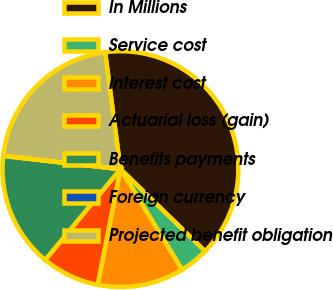<chart> <loc_0><loc_0><loc_500><loc_500><pie_chart><fcel>In Millions<fcel>Service cost<fcel>Interest cost<fcel>Actuarial loss (gain)<fcel>Benefits payments<fcel>Foreign currency<fcel>Projected benefit obligation<nl><fcel>39.34%<fcel>3.99%<fcel>11.84%<fcel>7.92%<fcel>15.77%<fcel>0.06%<fcel>21.08%<nl></chart> 